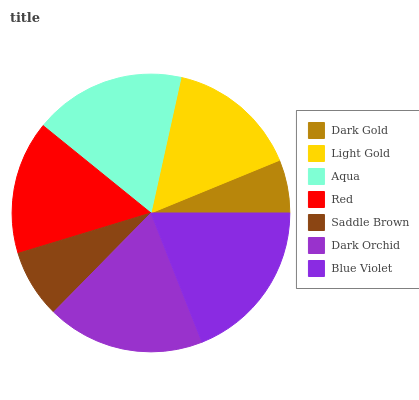Is Dark Gold the minimum?
Answer yes or no. Yes. Is Blue Violet the maximum?
Answer yes or no. Yes. Is Light Gold the minimum?
Answer yes or no. No. Is Light Gold the maximum?
Answer yes or no. No. Is Light Gold greater than Dark Gold?
Answer yes or no. Yes. Is Dark Gold less than Light Gold?
Answer yes or no. Yes. Is Dark Gold greater than Light Gold?
Answer yes or no. No. Is Light Gold less than Dark Gold?
Answer yes or no. No. Is Red the high median?
Answer yes or no. Yes. Is Red the low median?
Answer yes or no. Yes. Is Saddle Brown the high median?
Answer yes or no. No. Is Blue Violet the low median?
Answer yes or no. No. 